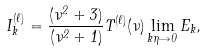Convert formula to latex. <formula><loc_0><loc_0><loc_500><loc_500>I ^ { ( \ell ) } _ { k } = \frac { ( \nu ^ { 2 } + 3 ) } { ( \nu ^ { 2 } + 1 ) } T ^ { ( \ell ) } ( \nu ) \lim _ { k \eta \rightarrow 0 } E _ { k } ,</formula> 